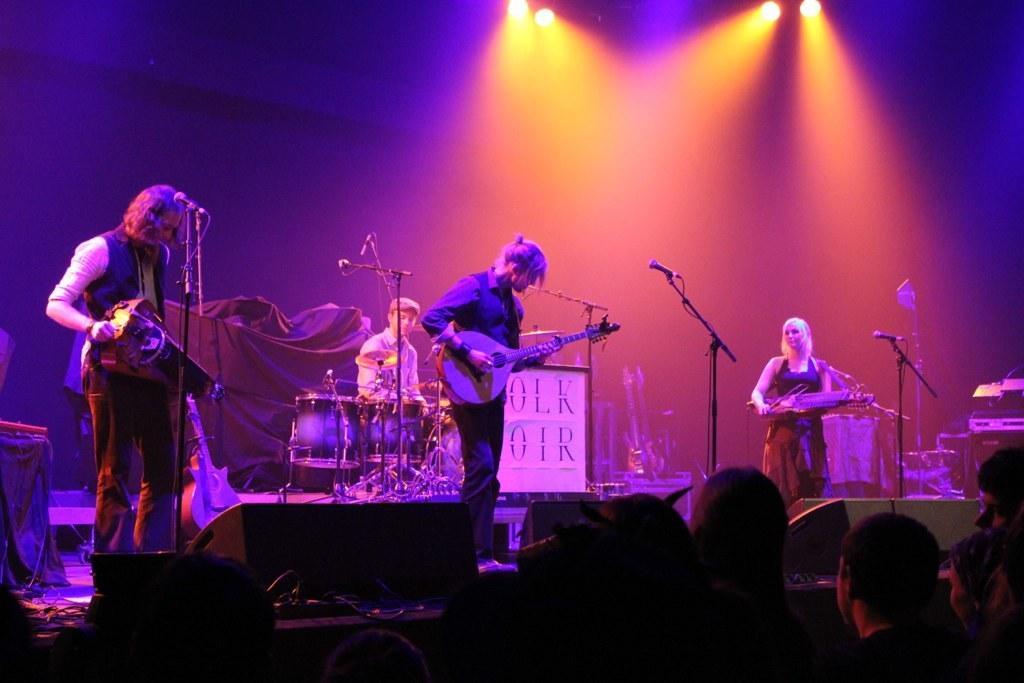Please provide a concise description of this image. There is a group of people. The three persons are standing on a stage. They are playing a musical instruments. In the center back side we have a one person. His sitting on a chair. 